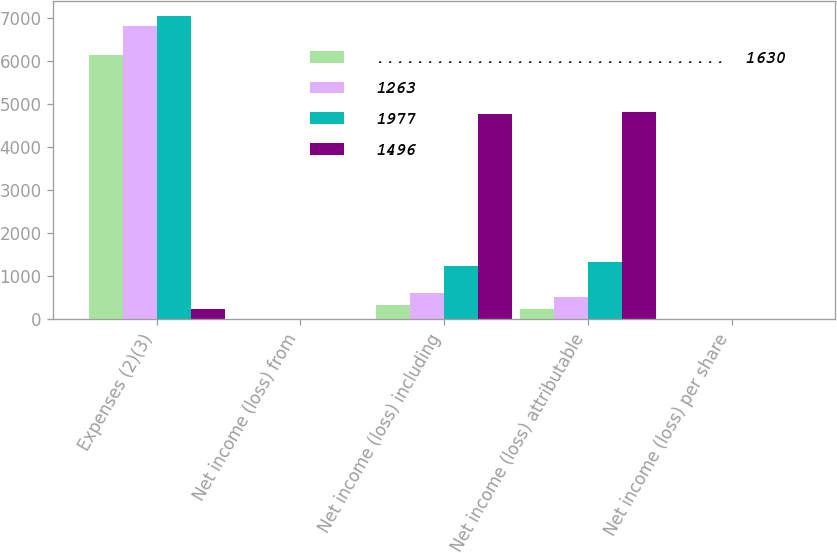Convert chart. <chart><loc_0><loc_0><loc_500><loc_500><stacked_bar_chart><ecel><fcel>Expenses (2)(3)<fcel>Net income (loss) from<fcel>Net income (loss) including<fcel>Net income (loss) attributable<fcel>Net income (loss) per share<nl><fcel>...................................  1630<fcel>6134<fcel>1.66<fcel>334<fcel>236<fcel>0.6<nl><fcel>1263<fcel>6809<fcel>1.17<fcel>613<fcel>505<fcel>1.31<nl><fcel>1977<fcel>7047<fcel>3.08<fcel>1241<fcel>1330<fcel>3.5<nl><fcel>1496<fcel>236<fcel>9.93<fcel>4766<fcel>4814<fcel>12.78<nl></chart> 